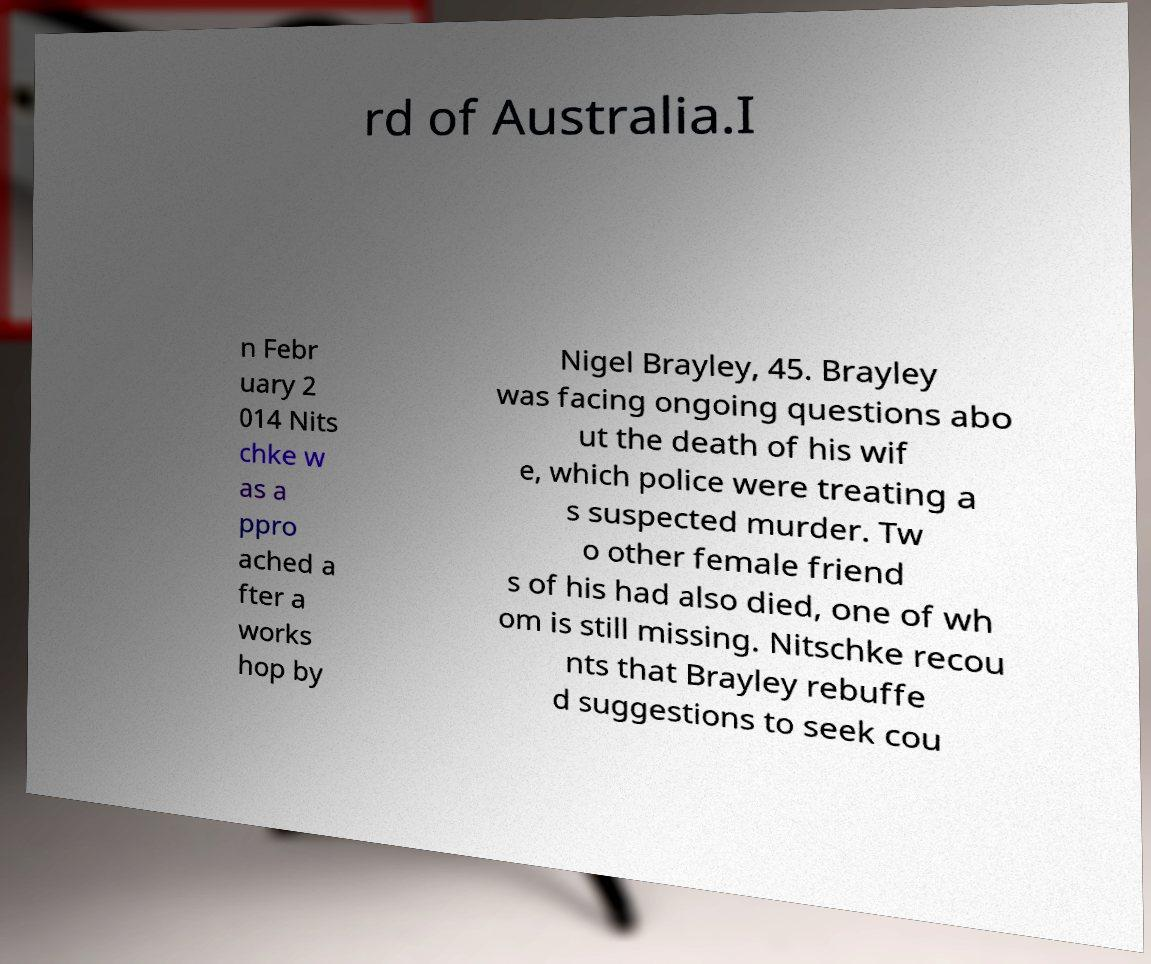What messages or text are displayed in this image? I need them in a readable, typed format. rd of Australia.I n Febr uary 2 014 Nits chke w as a ppro ached a fter a works hop by Nigel Brayley, 45. Brayley was facing ongoing questions abo ut the death of his wif e, which police were treating a s suspected murder. Tw o other female friend s of his had also died, one of wh om is still missing. Nitschke recou nts that Brayley rebuffe d suggestions to seek cou 